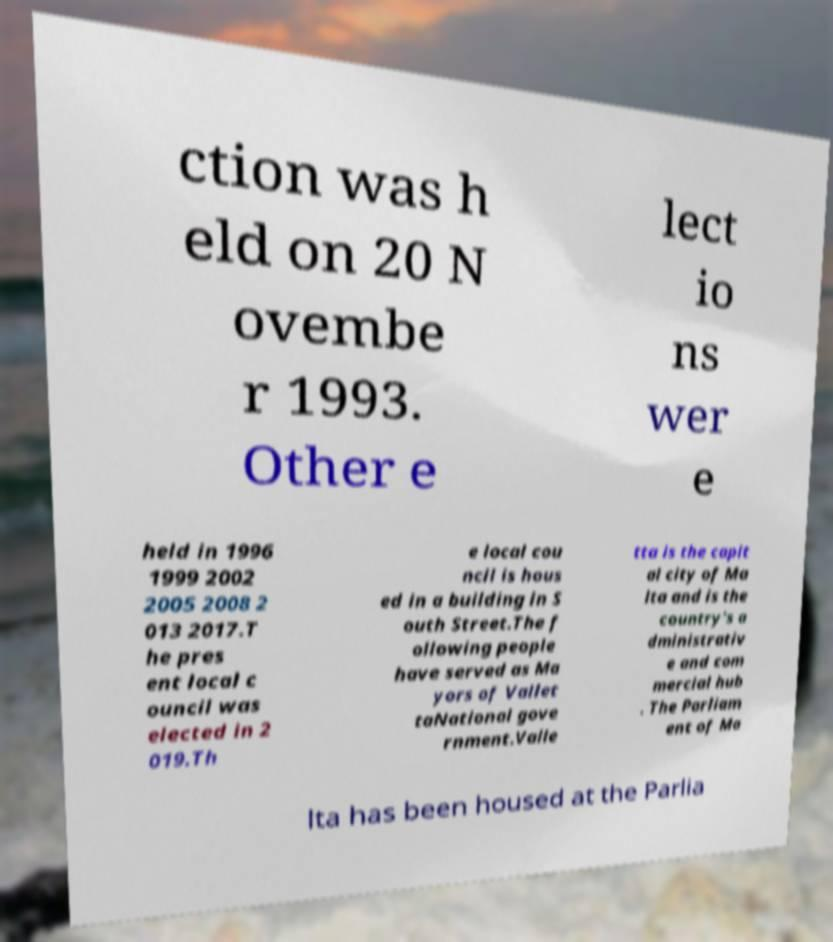Please read and relay the text visible in this image. What does it say? ction was h eld on 20 N ovembe r 1993. Other e lect io ns wer e held in 1996 1999 2002 2005 2008 2 013 2017.T he pres ent local c ouncil was elected in 2 019.Th e local cou ncil is hous ed in a building in S outh Street.The f ollowing people have served as Ma yors of Vallet taNational gove rnment.Valle tta is the capit al city of Ma lta and is the country's a dministrativ e and com mercial hub . The Parliam ent of Ma lta has been housed at the Parlia 